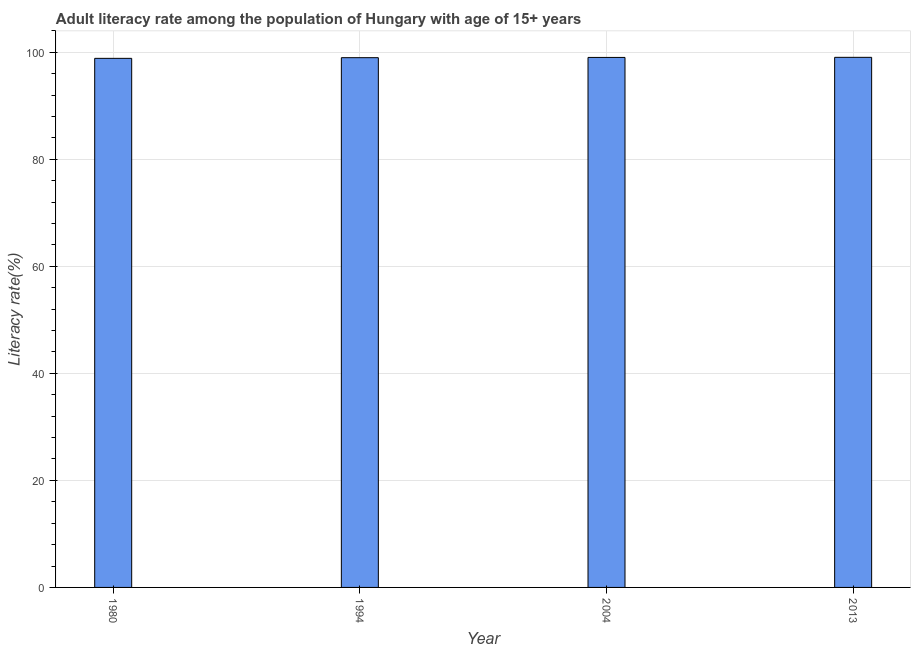Does the graph contain any zero values?
Provide a succinct answer. No. What is the title of the graph?
Offer a terse response. Adult literacy rate among the population of Hungary with age of 15+ years. What is the label or title of the X-axis?
Provide a short and direct response. Year. What is the label or title of the Y-axis?
Provide a succinct answer. Literacy rate(%). What is the adult literacy rate in 1994?
Offer a terse response. 98.98. Across all years, what is the maximum adult literacy rate?
Your answer should be compact. 99.05. Across all years, what is the minimum adult literacy rate?
Give a very brief answer. 98.86. What is the sum of the adult literacy rate?
Your answer should be compact. 395.92. What is the difference between the adult literacy rate in 1980 and 2013?
Offer a terse response. -0.19. What is the average adult literacy rate per year?
Offer a terse response. 98.98. What is the median adult literacy rate?
Give a very brief answer. 99.01. In how many years, is the adult literacy rate greater than 76 %?
Offer a terse response. 4. Do a majority of the years between 2013 and 1980 (inclusive) have adult literacy rate greater than 64 %?
Ensure brevity in your answer.  Yes. What is the ratio of the adult literacy rate in 1994 to that in 2004?
Your answer should be compact. 1. Is the adult literacy rate in 1980 less than that in 2013?
Your answer should be very brief. Yes. What is the difference between the highest and the second highest adult literacy rate?
Provide a succinct answer. 0.02. Is the sum of the adult literacy rate in 1980 and 2004 greater than the maximum adult literacy rate across all years?
Offer a terse response. Yes. What is the difference between the highest and the lowest adult literacy rate?
Offer a very short reply. 0.19. Are all the bars in the graph horizontal?
Offer a very short reply. No. How many years are there in the graph?
Give a very brief answer. 4. Are the values on the major ticks of Y-axis written in scientific E-notation?
Ensure brevity in your answer.  No. What is the Literacy rate(%) of 1980?
Your answer should be compact. 98.86. What is the Literacy rate(%) in 1994?
Provide a short and direct response. 98.98. What is the Literacy rate(%) in 2004?
Offer a terse response. 99.03. What is the Literacy rate(%) in 2013?
Offer a very short reply. 99.05. What is the difference between the Literacy rate(%) in 1980 and 1994?
Offer a terse response. -0.12. What is the difference between the Literacy rate(%) in 1980 and 2004?
Give a very brief answer. -0.17. What is the difference between the Literacy rate(%) in 1980 and 2013?
Give a very brief answer. -0.19. What is the difference between the Literacy rate(%) in 1994 and 2004?
Provide a short and direct response. -0.05. What is the difference between the Literacy rate(%) in 1994 and 2013?
Make the answer very short. -0.07. What is the difference between the Literacy rate(%) in 2004 and 2013?
Offer a terse response. -0.02. What is the ratio of the Literacy rate(%) in 1980 to that in 1994?
Your answer should be very brief. 1. What is the ratio of the Literacy rate(%) in 1980 to that in 2004?
Keep it short and to the point. 1. What is the ratio of the Literacy rate(%) in 1980 to that in 2013?
Ensure brevity in your answer.  1. What is the ratio of the Literacy rate(%) in 1994 to that in 2004?
Your response must be concise. 1. What is the ratio of the Literacy rate(%) in 1994 to that in 2013?
Ensure brevity in your answer.  1. 